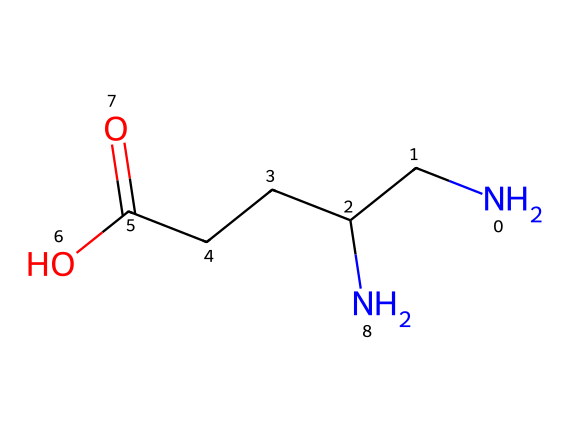What is the full name of the chemical represented by this SMILES? The SMILES notation reveals the presence of a primary amine group (N), indicating that this is an amino acid. The specific sequence of the atoms aligns with gamma-aminobutyric acid, commonly abbreviated as GABA.
Answer: gamma-aminobutyric acid How many nitrogen atoms are present in this structure? Analyzing the SMILES representation, there are two "N" symbols present, which represent nitrogen atoms in the structure.
Answer: 2 What functional group is represented by the “O=C(O)” portion of the structure? The “O=C(O)” notation indicates a carboxylic acid functional group. This is identified by the presence of a carbon atom double-bonded to an oxygen atom (C=O) and also bonded to a hydroxyl group (–OH).
Answer: carboxylic acid How does the structure of GABA relate to its role as a neurotransmitter? GABA's structural features, such as the presence of the amine groups (N) and the carboxylic acid (–COOH), allow it to interact with neurotransmitter receptors in the brain, promoting inhibitory signaling, which plays a key role in reducing anxiety and stress.
Answer: interacts with neurotransmitter receptors What is the total number of carbon atoms in this chemical structure? By counting the "C" symbols in the SMILES representation, there are four carbon atoms represented in the structure of GABA.
Answer: 4 Which part of the molecule is primarily responsible for its physiological effects? The amino acid group (–NH2) and the carboxylic acid group (–COOH) on GABA are crucial for its function as a neurotransmitter, facilitating its interactions with receptor sites in the brain.
Answer: amino and carboxylic groups 